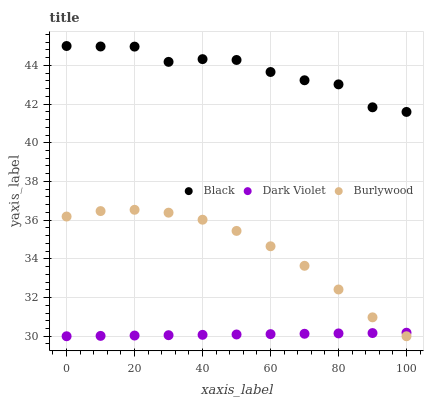Does Dark Violet have the minimum area under the curve?
Answer yes or no. Yes. Does Black have the maximum area under the curve?
Answer yes or no. Yes. Does Black have the minimum area under the curve?
Answer yes or no. No. Does Dark Violet have the maximum area under the curve?
Answer yes or no. No. Is Dark Violet the smoothest?
Answer yes or no. Yes. Is Black the roughest?
Answer yes or no. Yes. Is Black the smoothest?
Answer yes or no. No. Is Dark Violet the roughest?
Answer yes or no. No. Does Burlywood have the lowest value?
Answer yes or no. Yes. Does Black have the lowest value?
Answer yes or no. No. Does Black have the highest value?
Answer yes or no. Yes. Does Dark Violet have the highest value?
Answer yes or no. No. Is Burlywood less than Black?
Answer yes or no. Yes. Is Black greater than Dark Violet?
Answer yes or no. Yes. Does Burlywood intersect Dark Violet?
Answer yes or no. Yes. Is Burlywood less than Dark Violet?
Answer yes or no. No. Is Burlywood greater than Dark Violet?
Answer yes or no. No. Does Burlywood intersect Black?
Answer yes or no. No. 